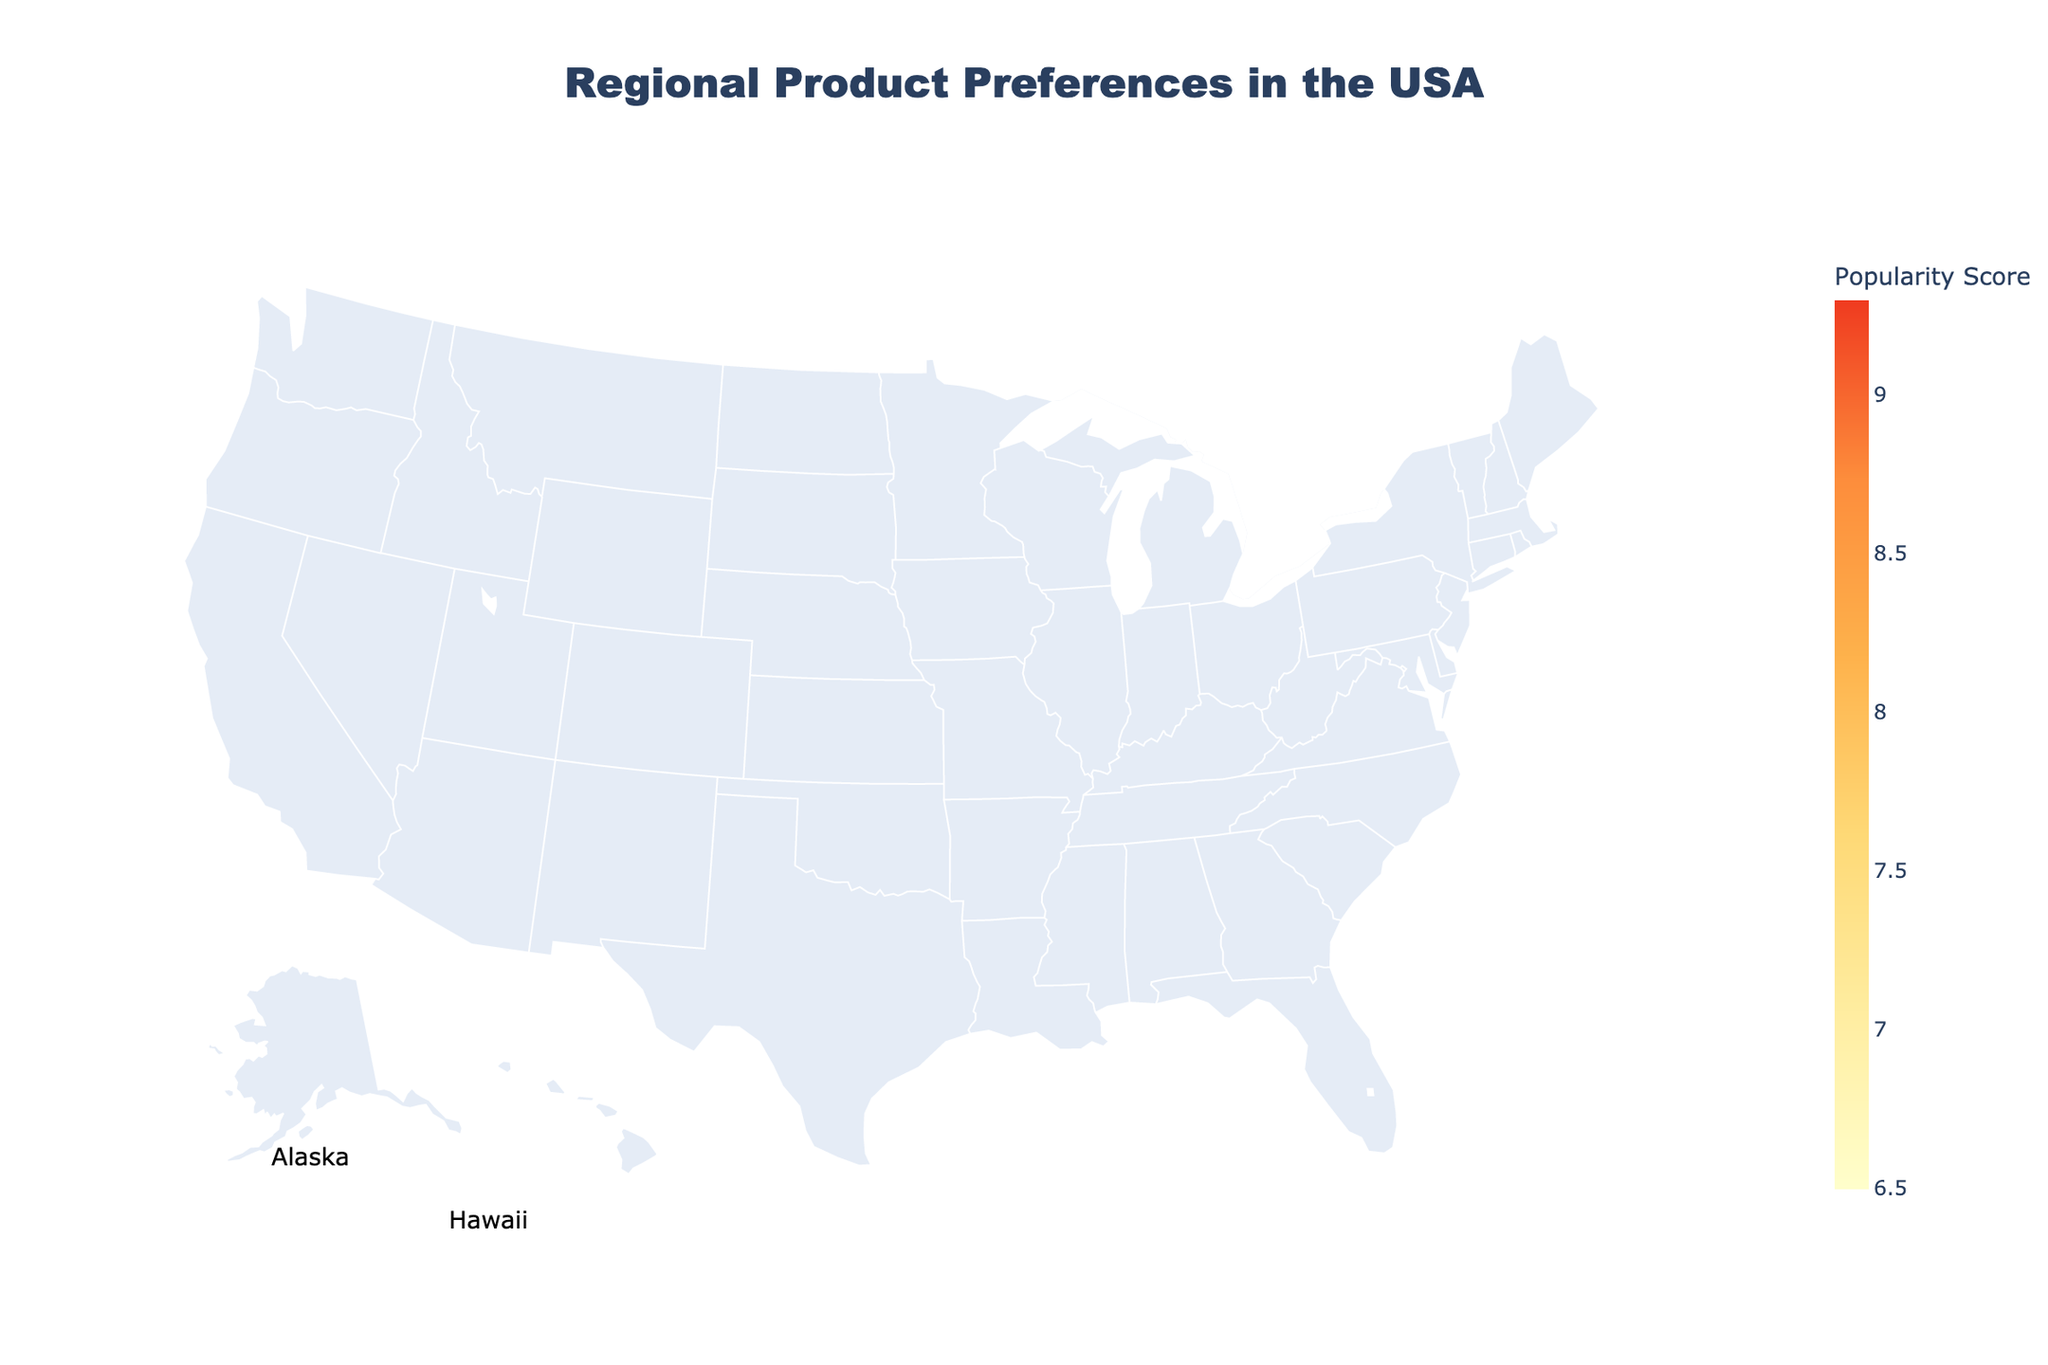What's the region with the highest popularity score? Identify the highest value among the popularity scores and find the corresponding region. The highest score is 9.3.
Answer: Pacific Northwest Which region prefers eco-friendly materials? Look at the column for the preferred feature and find the region that matches "eco-friendly materials".
Answer: Northeast Compare the popularity scores of the Northeast and the Southeast. Which one is higher? Locate the popularity scores of both the Northeast (8.5) and the Southeast (7.2). Compare the two values.
Answer: Northeast What is common in the preferred feature of Midwest and Rocky Mountains regions? Investigate the preferred features of both the Midwest (cost-effectiveness) and Rocky Mountains (outdoor adaptability) and check if there is any commonality. In this case, there's no common feature.
Answer: None Which region has the lowest popularity score, and what is its preferred feature? Identify the region with the lowest popularity score (6.5), and then look at its preferred feature.
Answer: Gulf Coast, Moisture protection What is the range of the popularity scores in the figure? Calculate the difference between the maximum popularity score (9.3) and the minimum (6.5).
Answer: 2.8 How many regions have a popularity score greater than 8? Count the regions with a popularity score higher than 8: Northeast (8.5), West Coast (8.9), Pacific Northwest (9.3), New England (8.2), Alaska (8.7).
Answer: 5 What packaging styles are preferred in the regions with the top three popularity scores? Identify the regions with the highest scores: Pacific Northwest (9.3), Midwest (9.1), West Coast (8.9). Then, find out their preferred packaging styles: Nature-themed packaging, Family-sized packaging, Sleek and modern.
Answer: Nature-themed packaging, Family-sized packaging, Sleek and modern Are there any regions that prefer both eco-friendly materials and minimalist design? Check if any region lists both "eco-friendly materials" for the preferred feature and "minimalist design" for the packaging style. The Northeast meets both conditions.
Answer: Northeast Among the listed regions, which one prefers durability as a product feature, and what is its corresponding popularity score? Find the region that lists "durability" as the preferred feature (Southeast) and note its popularity score (7.2).
Answer: Southeast, 7.2 